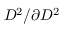Convert formula to latex. <formula><loc_0><loc_0><loc_500><loc_500>D ^ { 2 } / \partial { D ^ { 2 } }</formula> 